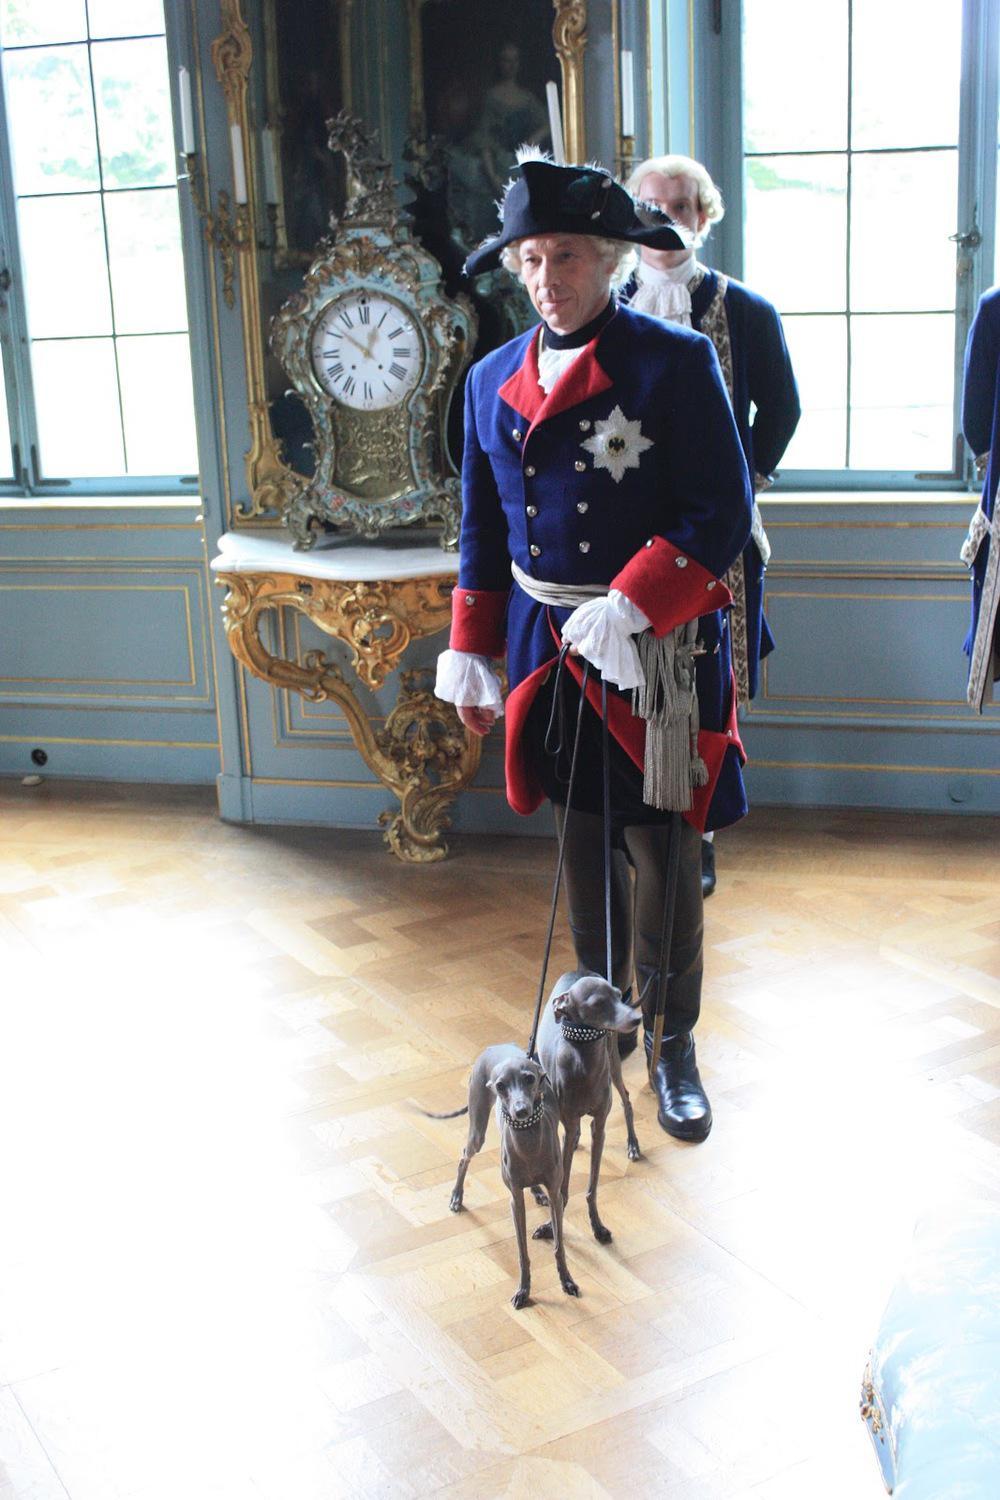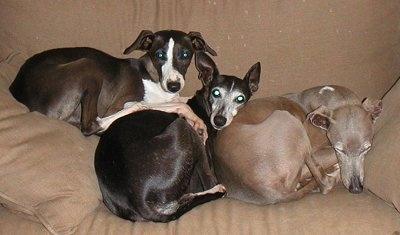The first image is the image on the left, the second image is the image on the right. Examine the images to the left and right. Is the description "All dogs are wearing fancy, colorful collars." accurate? Answer yes or no. No. The first image is the image on the left, the second image is the image on the right. Given the left and right images, does the statement "There are more dogs in the right image than in the left." hold true? Answer yes or no. Yes. 